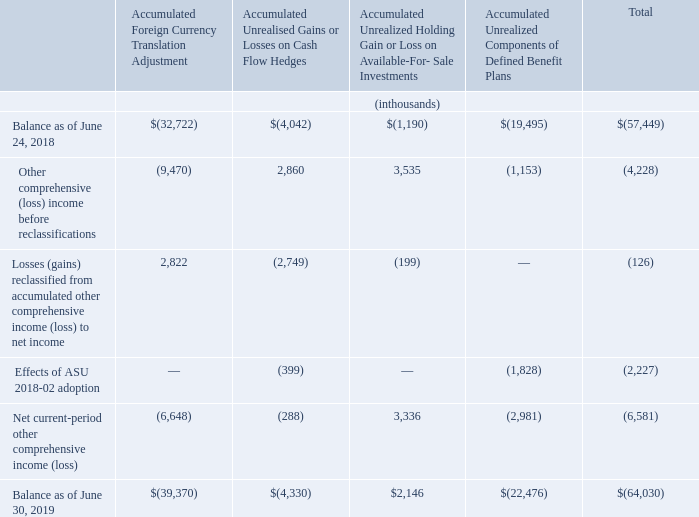Note 18: Comprehensive Income (Loss)
The components of accumulated other comprehensive loss, net of tax at the end of June 30, 2019, as well as the activity during the fiscal year ended June 30, 2019, were as follows:
(1) Amount of after-tax gain reclassified from accumulated other comprehensive income into net income located in other expense, net.
(2) Amount of after-tax gain reclassified from accumulated other comprehensive income into net income located in revenue: $9.6 million gain; cost of goods sold: $5.0 million loss; selling, general, and administrative expenses: $1.7 million loss; and other income and expense: $0.1 million loss.
Tax related to other comprehensive income, and the components thereto, for the years ended June 30, 2019, June 24, 2018 and June 25, 2017 was not material.
What is the Amount of after-tax gain reclassified from accumulated other comprehensive income into net income located in revenue? $9.6 million gain. What is the Amount of after-tax loss reclassified from accumulated other comprehensive income into net income located in selling, general, and administrative expenses? $1.7 million loss. What is the Amount of after-tax loss reclassified from accumulated other comprehensive income into net income located in cost of goods sold? $5.0 million loss. What is the percentage change in the total balance from 2018 to 2019?
Answer scale should be: percent. (64,030-57,449)/57,449
Answer: 11.46. Under the Accumulated Foreign Currency Translation Adjustment, what is the percentage change in the balance from 2018 to 2019?
Answer scale should be: percent. (39,370-32,722)/32,722
Answer: 20.32. Under the Accumulated Unrealized Components of Defined Benefit Plans, what is the percentage change in the balance from 2018 to 2019?
Answer scale should be: percent. (22,476-19,495)/19,495
Answer: 15.29. 